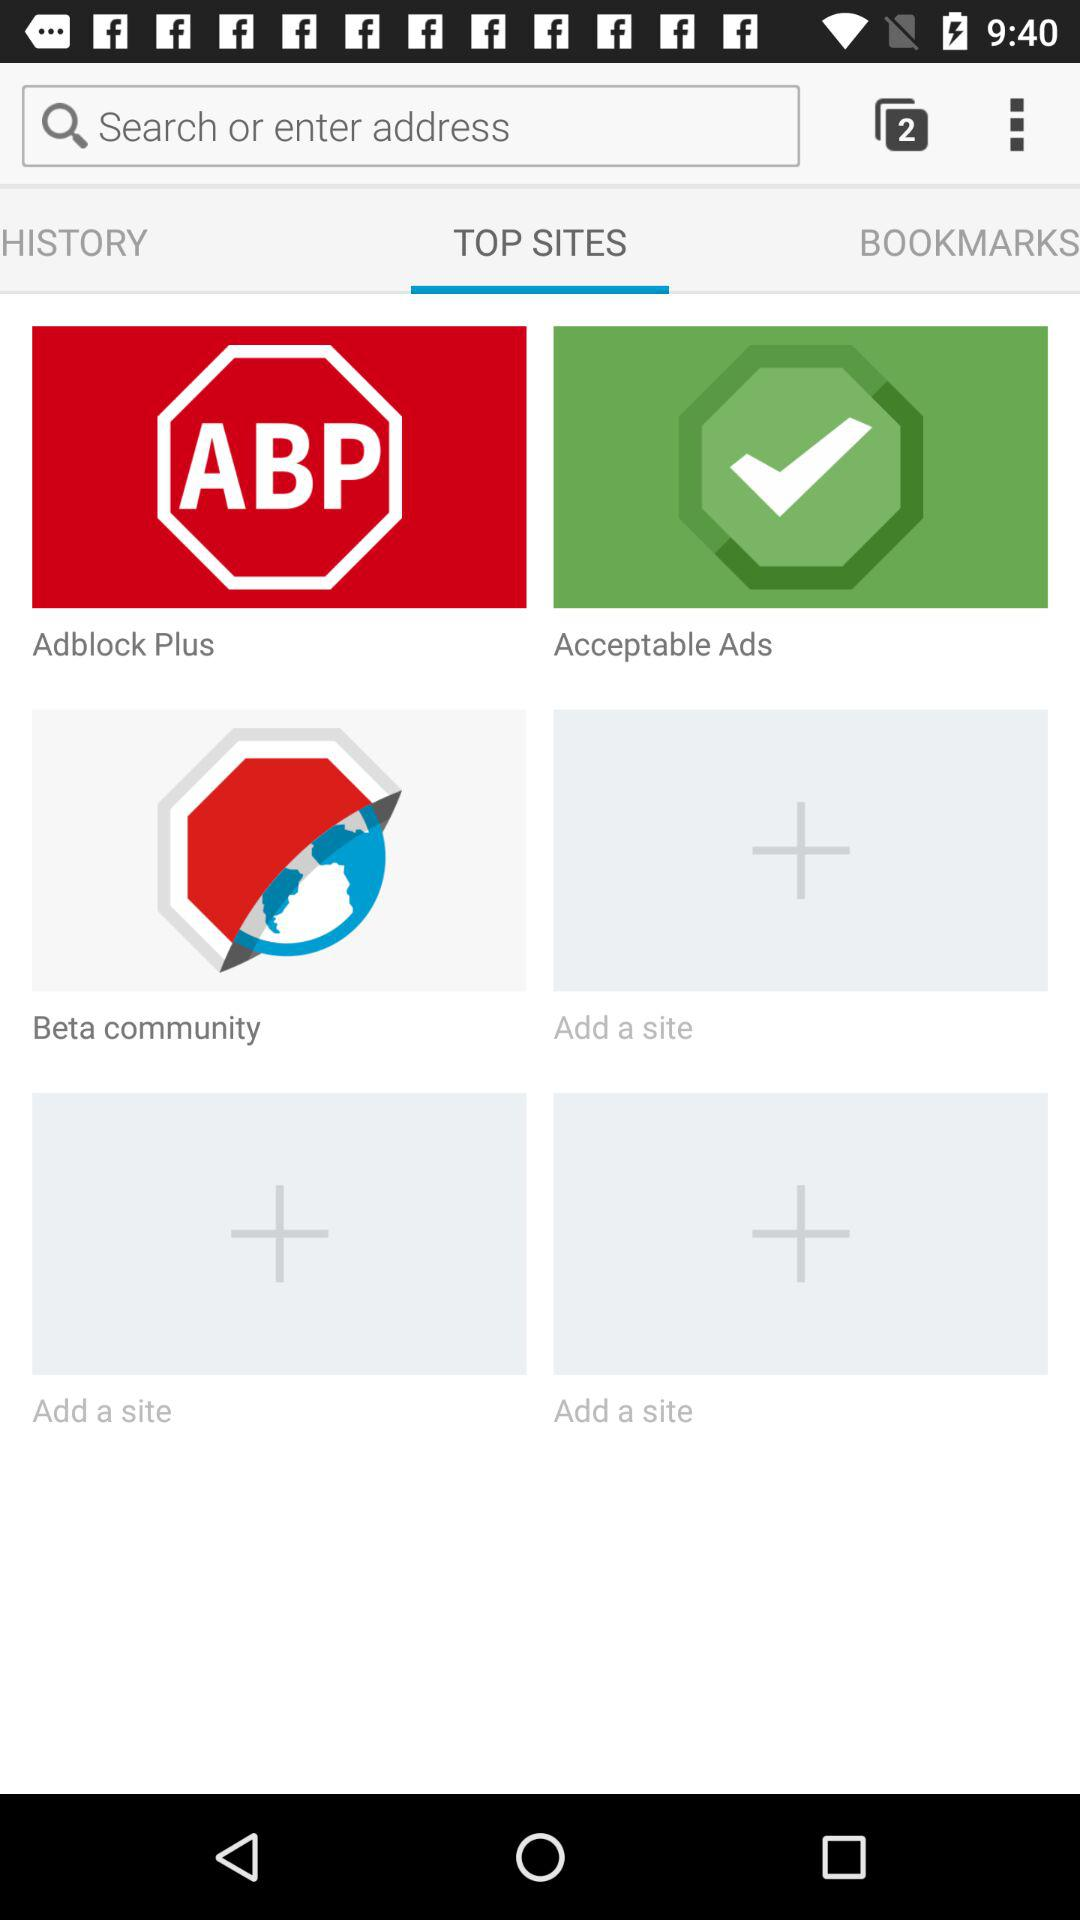Which tab am I using? You are using the "TOP SITES" tab. 